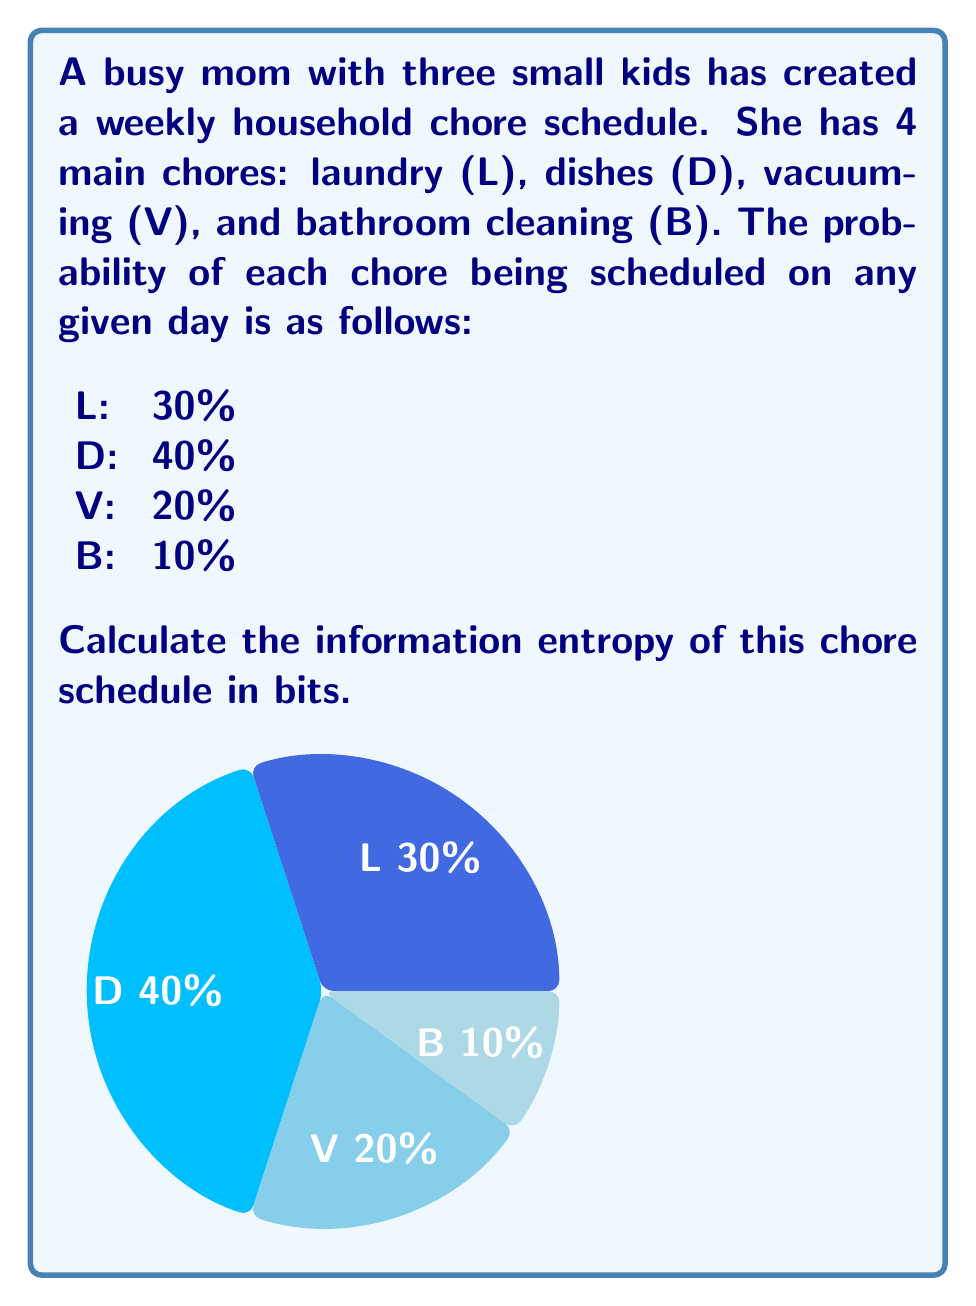Show me your answer to this math problem. To calculate the information entropy of the chore schedule, we'll use the formula:

$$H = -\sum_{i=1}^{n} p_i \log_2(p_i)$$

Where $H$ is the entropy, $p_i$ is the probability of each event, and $n$ is the number of possible events.

Step 1: Calculate each term in the sum:
1. For Laundry (L): $-0.3 \log_2(0.3)$
2. For Dishes (D): $-0.4 \log_2(0.4)$
3. For Vacuuming (V): $-0.2 \log_2(0.2)$
4. For Bathroom cleaning (B): $-0.1 \log_2(0.1)$

Step 2: Calculate each logarithm:
1. $\log_2(0.3) \approx -1.7370$
2. $\log_2(0.4) \approx -1.3219$
3. $\log_2(0.2) \approx -2.3219$
4. $\log_2(0.1) \approx -3.3219$

Step 3: Multiply each probability by its log and sum:
$$H = (-0.3 \times -1.7370) + (-0.4 \times -1.3219) + (-0.2 \times -2.3219) + (-0.1 \times -3.3219)$$

Step 4: Simplify:
$$H = 0.5211 + 0.5288 + 0.4644 + 0.3322$$

Step 5: Sum up the results:
$$H = 1.8465$$

Therefore, the information entropy of the chore schedule is approximately 1.8465 bits.
Answer: 1.8465 bits 